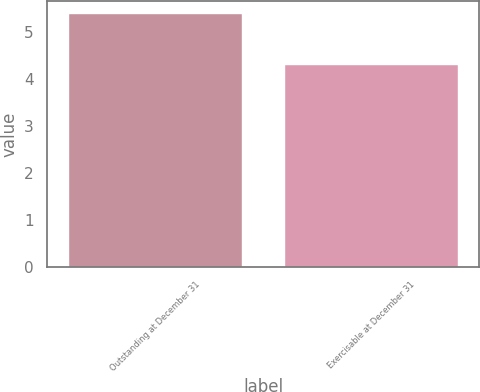Convert chart to OTSL. <chart><loc_0><loc_0><loc_500><loc_500><bar_chart><fcel>Outstanding at December 31<fcel>Exercisable at December 31<nl><fcel>5.4<fcel>4.3<nl></chart> 